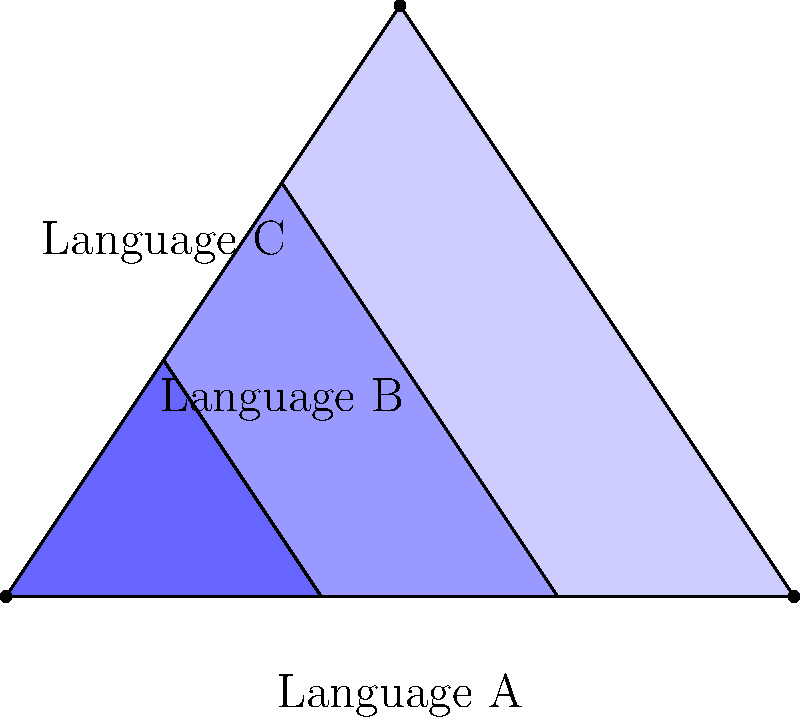In a language distribution mapping project, you use a triangular region to represent a multilingual area. The triangle is divided into three nested sections, with the innermost section representing the most widely spoken language. If the total area of the triangle is 6 square units, and each nested section's area is half of the section that contains it, what is the area of the region representing the second most widely spoken language (Language B)? To solve this problem, let's follow these steps:

1. Understand the given information:
   - The total area of the triangle is 6 square units.
   - Each nested section's area is half of the section that contains it.
   - We need to find the area of the middle section (Language B).

2. Let's define the areas:
   - Let $A$ be the area of the largest section (Language A)
   - Let $B$ be the area of the middle section (Language B)
   - Let $C$ be the area of the innermost section (Language C)

3. Set up equations based on the given information:
   - $A + B + C = 6$ (total area)
   - $B = \frac{1}{2}(A + B)$ (B is half of the area that contains it)
   - $C = \frac{1}{2}B$ (C is half of B)

4. Solve for B:
   - From the third equation: $C = \frac{1}{2}B$
   - Substitute this into the first equation: $A + B + \frac{1}{2}B = 6$
   - Simplify: $A + \frac{3}{2}B = 6$ ... (1)

   - From the second equation: $B = \frac{1}{2}(A + B)$
   - Multiply both sides by 2: $2B = A + B$
   - Subtract B from both sides: $B = A$ ... (2)

   - Substitute (2) into (1): $B + \frac{3}{2}B = 6$
   - Simplify: $\frac{5}{2}B = 6$
   - Solve for B: $B = \frac{6}{\frac{5}{2}} = \frac{12}{5} = 2.4$

Therefore, the area of the region representing Language B is 2.4 square units.
Answer: 2.4 square units 